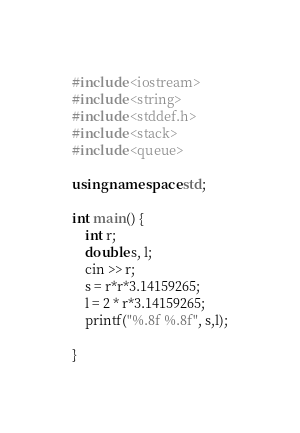Convert code to text. <code><loc_0><loc_0><loc_500><loc_500><_C++_>#include <iostream>
#include <string>
#include <stddef.h>
#include <stack>
#include <queue>

using namespace std;

int main() {
	int r;
	double s, l;
	cin >> r;
	s = r*r*3.14159265;
	l = 2 * r*3.14159265;
	printf("%.8f %.8f", s,l);
	
}</code> 